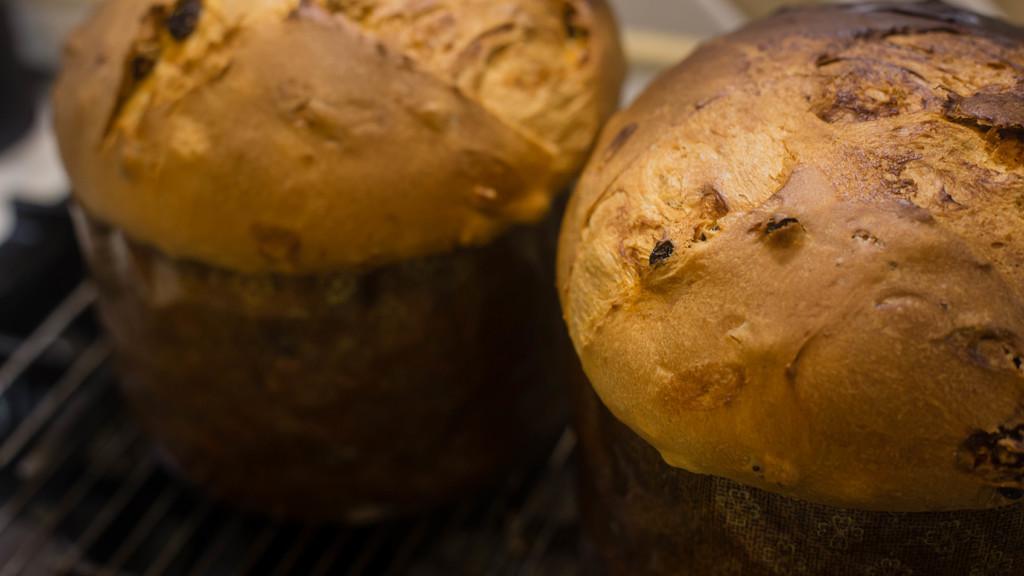Describe this image in one or two sentences. In this picture we can see food items. 